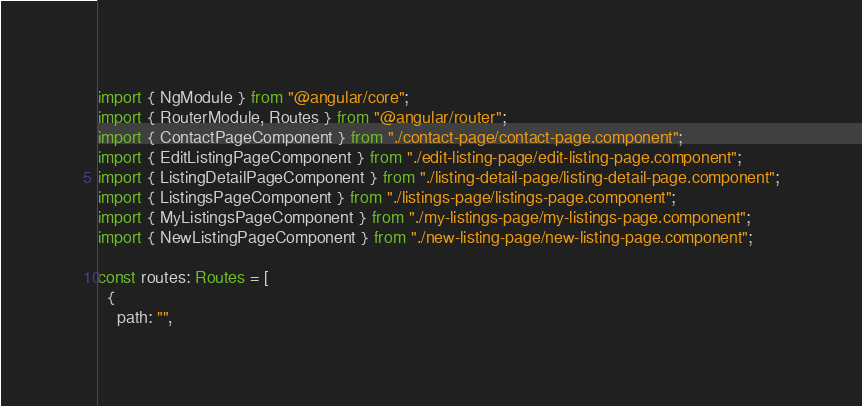Convert code to text. <code><loc_0><loc_0><loc_500><loc_500><_TypeScript_>import { NgModule } from "@angular/core";
import { RouterModule, Routes } from "@angular/router";
import { ContactPageComponent } from "./contact-page/contact-page.component";
import { EditListingPageComponent } from "./edit-listing-page/edit-listing-page.component";
import { ListingDetailPageComponent } from "./listing-detail-page/listing-detail-page.component";
import { ListingsPageComponent } from "./listings-page/listings-page.component";
import { MyListingsPageComponent } from "./my-listings-page/my-listings-page.component";
import { NewListingPageComponent } from "./new-listing-page/new-listing-page.component";

const routes: Routes = [
  {
    path: "",</code> 